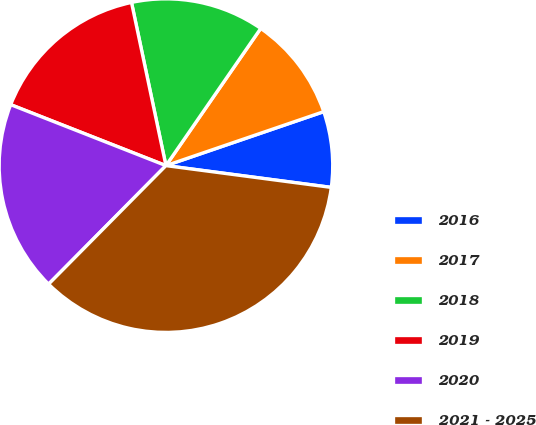<chart> <loc_0><loc_0><loc_500><loc_500><pie_chart><fcel>2016<fcel>2017<fcel>2018<fcel>2019<fcel>2020<fcel>2021 - 2025<nl><fcel>7.33%<fcel>10.13%<fcel>12.93%<fcel>15.73%<fcel>18.53%<fcel>35.33%<nl></chart> 